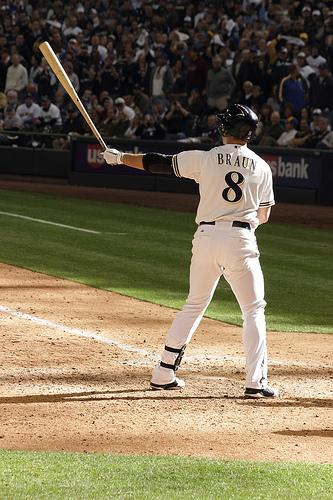Question: why is he standing there?
Choices:
A. To watch the players.
B. To play volleyball.
C. To golf.
D. He is batting.
Answer with the letter. Answer: D Question: what game is this?
Choices:
A. Golf.
B. Tennis.
C. Basketball.
D. Baseball.
Answer with the letter. Answer: D Question: what time of day is this?
Choices:
A. Nighttime.
B. Sunrise.
C. Daytime.
D. Sunset.
Answer with the letter. Answer: C 